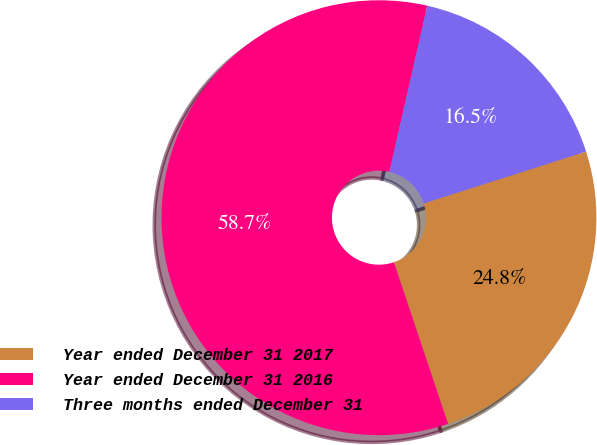Convert chart to OTSL. <chart><loc_0><loc_0><loc_500><loc_500><pie_chart><fcel>Year ended December 31 2017<fcel>Year ended December 31 2016<fcel>Three months ended December 31<nl><fcel>24.77%<fcel>58.72%<fcel>16.51%<nl></chart> 